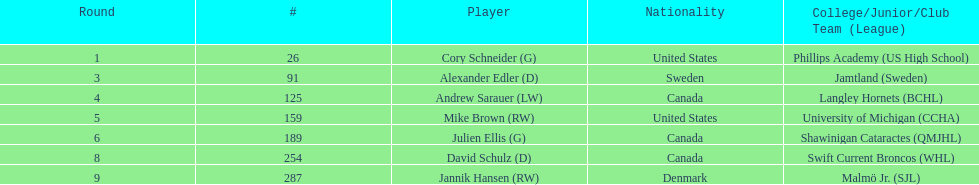Which players are not from denmark? Cory Schneider (G), Alexander Edler (D), Andrew Sarauer (LW), Mike Brown (RW), Julien Ellis (G), David Schulz (D). Write the full table. {'header': ['Round', '#', 'Player', 'Nationality', 'College/Junior/Club Team (League)'], 'rows': [['1', '26', 'Cory Schneider (G)', 'United States', 'Phillips Academy (US High School)'], ['3', '91', 'Alexander Edler (D)', 'Sweden', 'Jamtland (Sweden)'], ['4', '125', 'Andrew Sarauer (LW)', 'Canada', 'Langley Hornets (BCHL)'], ['5', '159', 'Mike Brown (RW)', 'United States', 'University of Michigan (CCHA)'], ['6', '189', 'Julien Ellis (G)', 'Canada', 'Shawinigan Cataractes (QMJHL)'], ['8', '254', 'David Schulz (D)', 'Canada', 'Swift Current Broncos (WHL)'], ['9', '287', 'Jannik Hansen (RW)', 'Denmark', 'Malmö Jr. (SJL)']]} 